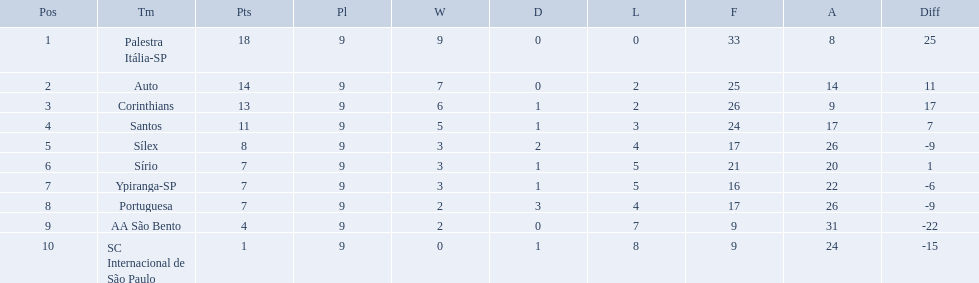What teams played in 1926? Palestra Itália-SP, Auto, Corinthians, Santos, Sílex, Sírio, Ypiranga-SP, Portuguesa, AA São Bento, SC Internacional de São Paulo. Did any team lose zero games? Palestra Itália-SP. Brazilian football in 1926 what teams had no draws? Palestra Itália-SP, Auto, AA São Bento. Of the teams with no draws name the 2 who lost the lease. Palestra Itália-SP, Auto. What team of the 2 who lost the least and had no draws had the highest difference? Palestra Itália-SP. 